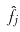<formula> <loc_0><loc_0><loc_500><loc_500>\hat { f _ { j } }</formula> 